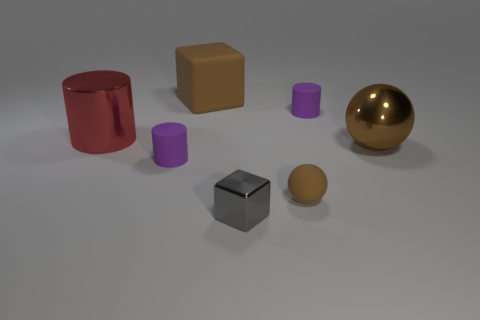Add 2 small shiny objects. How many objects exist? 9 Subtract all balls. How many objects are left? 5 Add 1 tiny brown matte objects. How many tiny brown matte objects are left? 2 Add 2 shiny cylinders. How many shiny cylinders exist? 3 Subtract 0 blue cubes. How many objects are left? 7 Subtract all large cyan rubber objects. Subtract all large red cylinders. How many objects are left? 6 